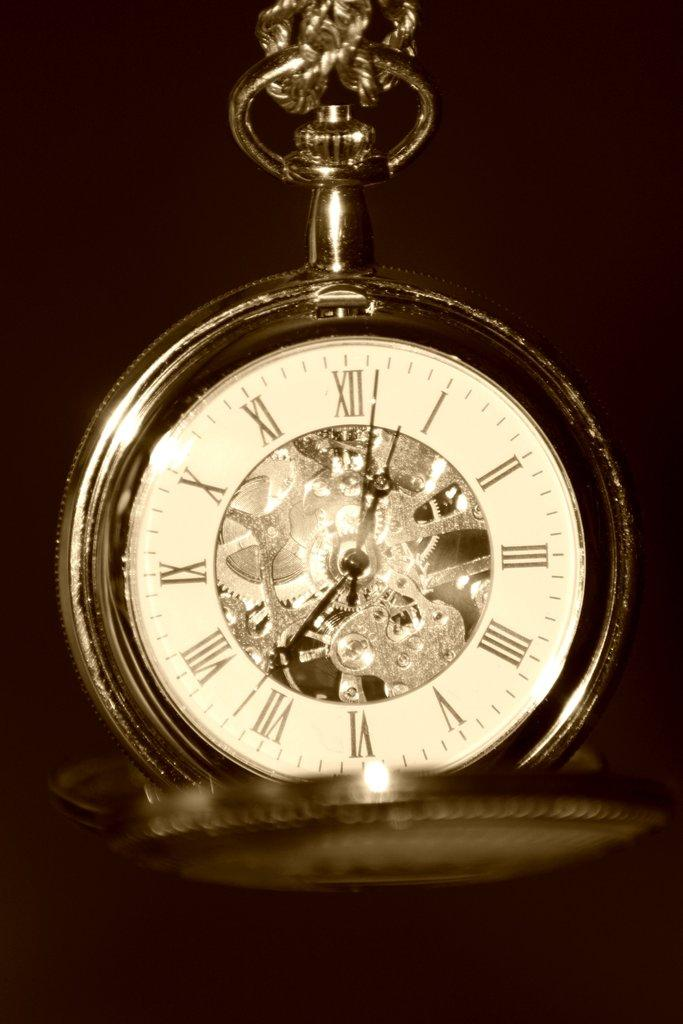Provide a one-sentence caption for the provided image. Clock that is in roman numerals that is sitting by itself. 